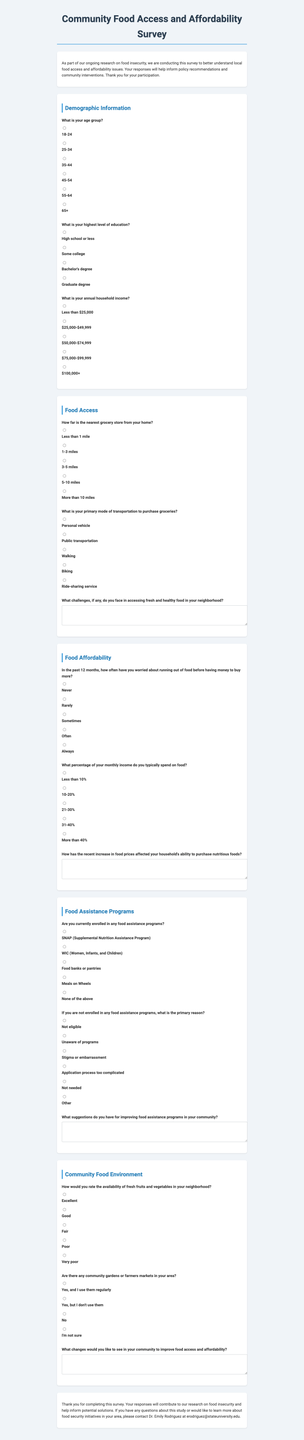What is the title of the survey? The title is the first text in the document, which introduces the survey.
Answer: Community Food Access and Affordability Survey What is the age group with the highest option available? The age group options are listed in the demographic section.
Answer: 65+ What is the primary mode of transportation to purchase groceries? This question asks respondents to select their primary way to buy groceries.
Answer: Personal vehicle How often have respondents worried about running out of food? This question asks about food worry frequency in the past year.
Answer: Often What is the expected response for food assistance program enrollment? This question inquires whether respondents are enrolled in any food assistance programs.
Answer: None of the above What percentage of monthly income is spent on food? The question asks respondents to indicate the percentage of their income allocated to food expenses.
Answer: 10-20% What feedback is requested regarding food assistance programs? This prompt asks for suggestions to enhance or improve food assistance initiatives.
Answer: Suggestions How are the availability of fresh fruits and vegetables rated? This question inquires about respondents' ratings on local produce availability.
Answer: Good Are there community gardens or farmers markets in the area? This question asks for the existence of local community gardens or markets.
Answer: Yes, and I use them regularly 